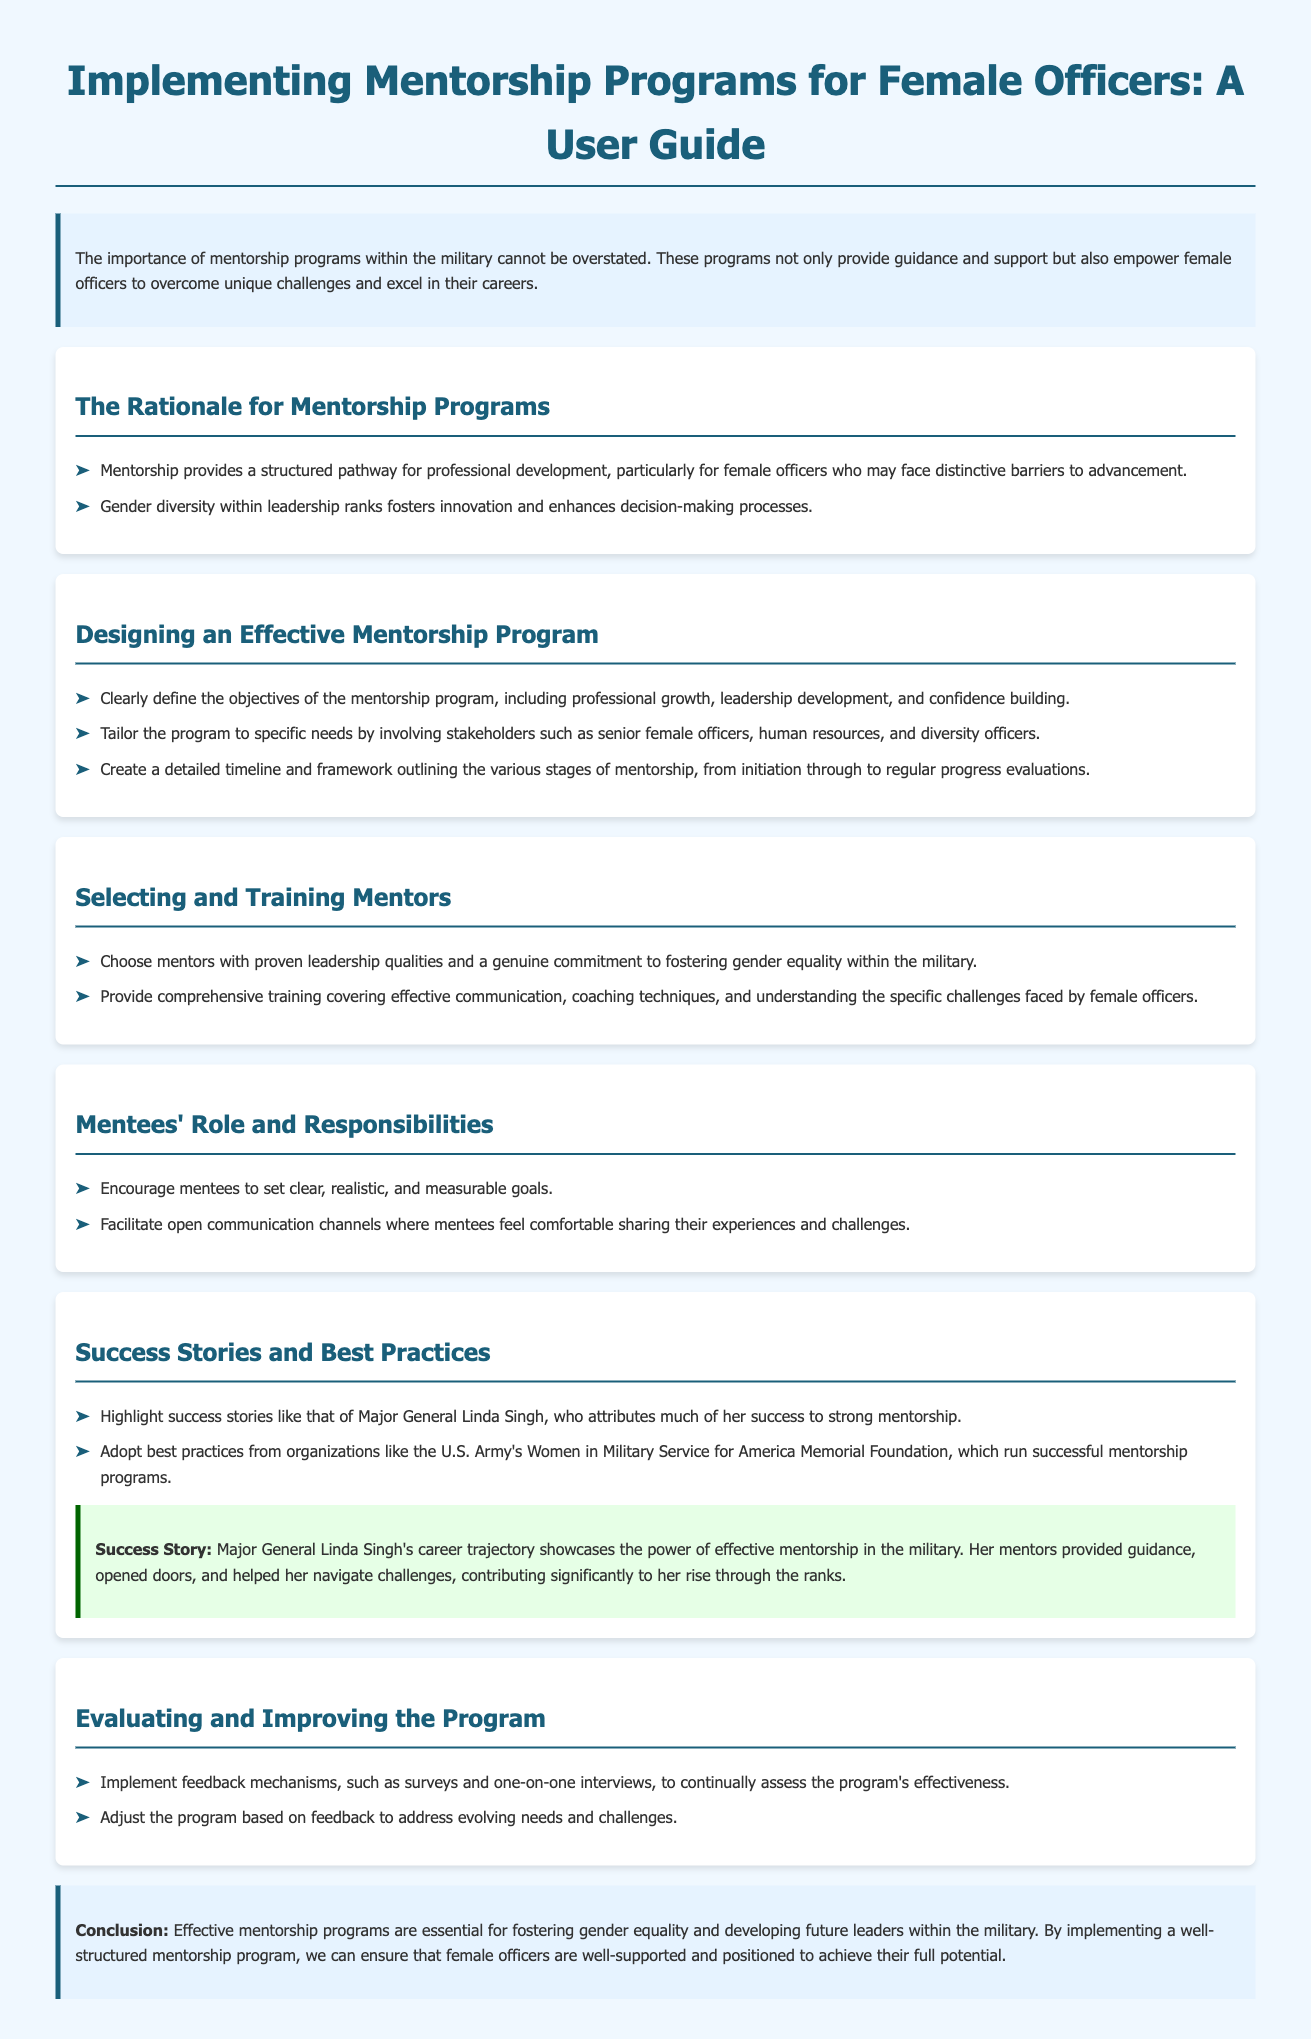What is the title of the document? The title of the document is found at the top of the rendered page.
Answer: Implementing Mentorship Programs for Female Officers: A User Guide What is one key benefit of mentorship mentioned? The key benefit can be found in the section titled "The Rationale for Mentorship Programs."
Answer: Guidance and support Who is an example of a successful mentee mentioned in the document? The successful mentee is highlighted in the "Success Stories and Best Practices" section.
Answer: Major General Linda Singh What is one responsibility of mentees? The responsibilities of mentees are described in the "Mentees' Role and Responsibilities" section.
Answer: Set clear goals What should be included in the program evaluation? The evaluation mechanisms are mentioned in the section titled "Evaluating and Improving the Program."
Answer: Feedback mechanisms Which organization is cited for best practices? The organization is referenced in the "Success Stories and Best Practices" section.
Answer: U.S. Army's Women in Military Service for America Memorial Foundation What is the primary goal of designing a mentorship program? The primary goal is outlined in the "Designing an Effective Mentorship Program" section.
Answer: Professional growth What color is used for the document's background? The background color is indicated in the document style.
Answer: #f0f8ff 